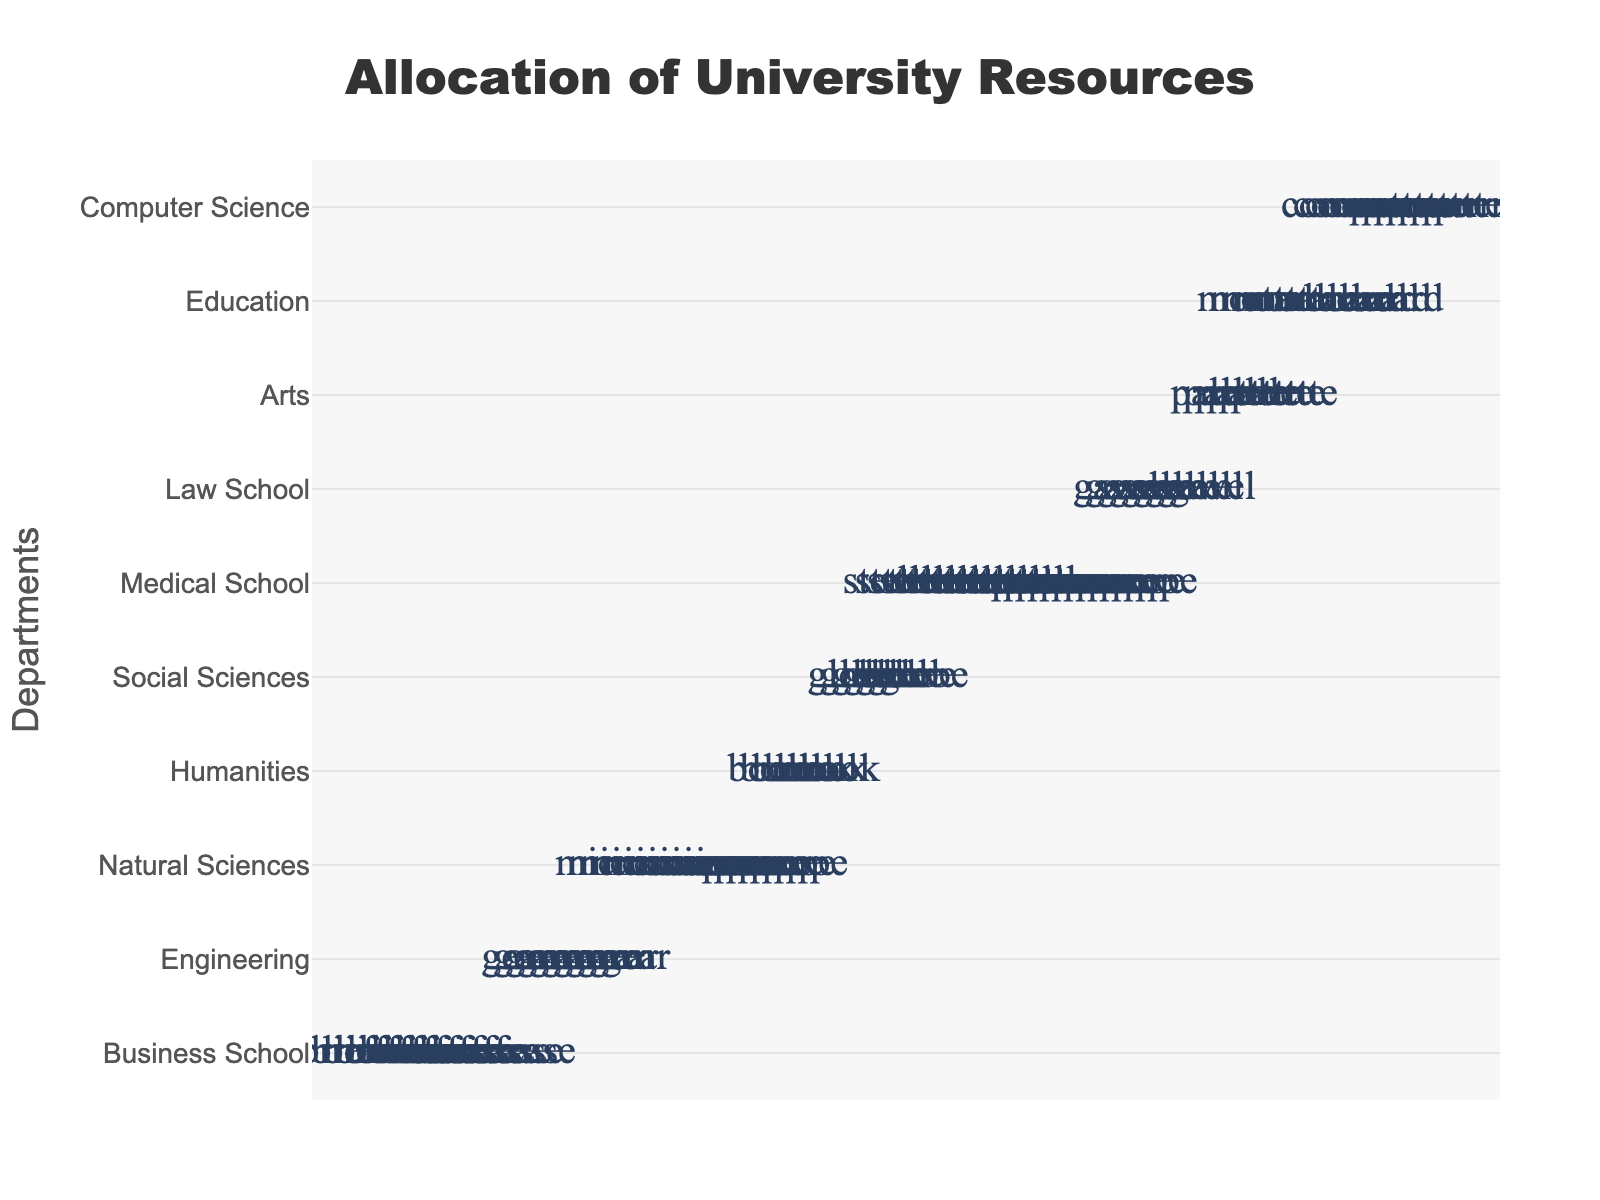what is the title of the plot? The title of the plot is positioned at the top and is displayed in a prominent font that reads 'Allocation of University Resources'.
Answer: Allocation of University Resources Which department has the highest allocated budget? The department with the most icons represents the highest allocated budget. The Medical School has the most icons.
Answer: Medical School How many icons are there for the Engineering department? By counting the icons next to the Engineering department, you can see there are 11 icons.
Answer: 11 Which department has the lowest allocation in million USD? The department with the fewest icons represents the lowest budget. The Education department has the fewest icons.
Answer: Education What is the cumulative budget of the Business School and Law School? The Business School and Law School have 25 and 18 million USD respectively. Adding these gives 25 + 18 = 43 million USD.
Answer: 43 million USD How many departments have an allocated budget greater than 15 million USD? Count the departments with more than 7 icons (as each icon represents 2 million USD). Business School, Engineering, Natural Sciences, Medical School, and Law School each have more than 7 icons.
Answer: 5 Which department has a higher allocated budget: the Arts or Computer Science? Compare the number of icons for both departments. Computer Science has 8 icons, while Arts has 6.
Answer: Computer Science What is the difference in budget allocation between Humanities and Social Sciences? The Humanities have 15 million USD (7.5 icons) and Social Sciences have 14 million USD (7 icons). The difference is 15 - 14 = 1 million USD.
Answer: 1 million USD Which departments have the same budget allocation? Look for departments with an equal number of icons. The Social Sciences and Humanities both have 7 icons, but none are exactly equal.
Answer: None If the total budget allocation for all departments is $202 million, what percentage is allocated to the Engineering department? The Engineering department has a budget of 22 million USD. To find the percentage: (22/202) * 100 = 10.89%.
Answer: 10.89% 